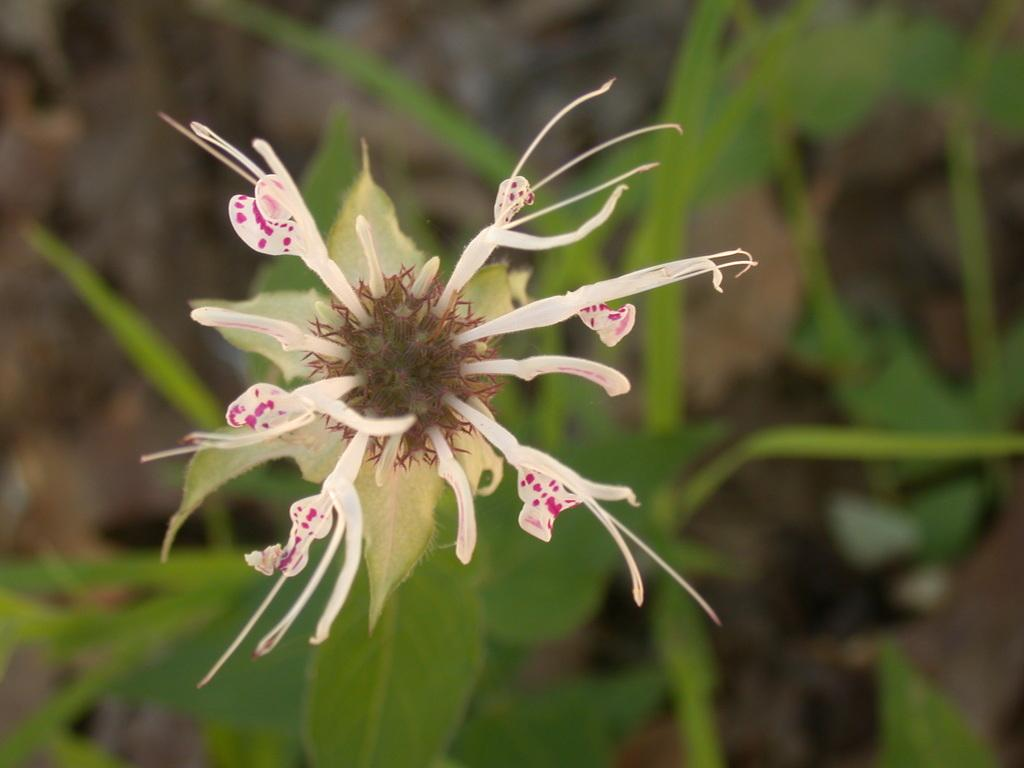What is the main subject of the image? There is a flower in the image. What can be seen at the bottom of the image? There are leaves at the bottom of the image. How does the flower guide people in the image? The flower does not guide people in the image; it is a static object. 